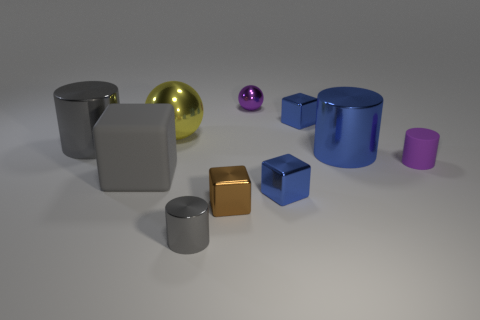What number of other objects are the same size as the gray rubber object?
Provide a short and direct response. 3. Is the tiny metal sphere the same color as the small rubber cylinder?
Keep it short and to the point. Yes. There is a large yellow thing that is the same shape as the purple metal object; what is its material?
Keep it short and to the point. Metal. Are there an equal number of tiny metal objects that are on the left side of the purple shiny ball and metal cubes to the right of the brown shiny thing?
Your response must be concise. Yes. Do the large gray cube and the purple cylinder have the same material?
Provide a short and direct response. Yes. What number of gray objects are big rubber cubes or tiny cylinders?
Ensure brevity in your answer.  2. How many tiny objects have the same shape as the large yellow object?
Offer a very short reply. 1. What material is the big blue object?
Provide a short and direct response. Metal. Are there an equal number of large gray cubes on the left side of the gray rubber thing and brown metal blocks?
Your answer should be compact. No. There is a yellow shiny thing that is the same size as the gray rubber block; what shape is it?
Your response must be concise. Sphere. 